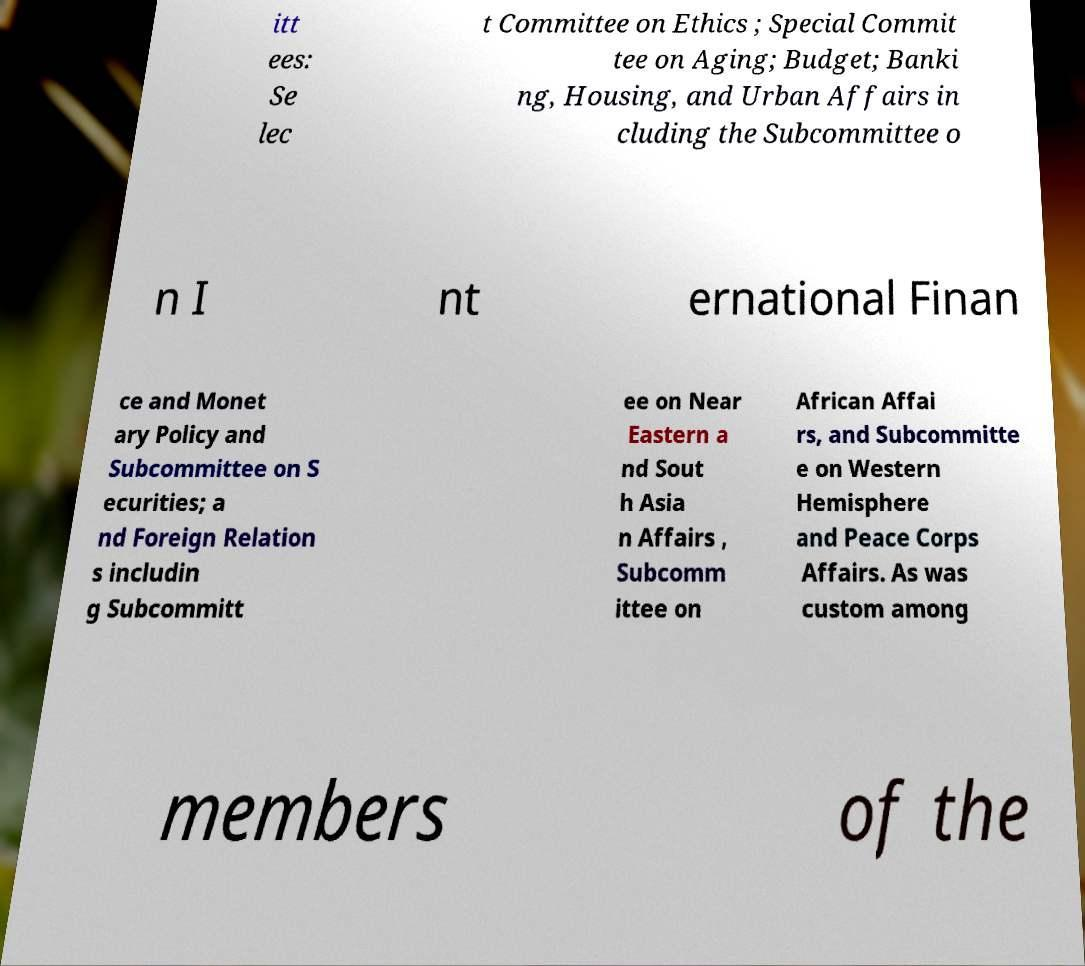Please identify and transcribe the text found in this image. itt ees: Se lec t Committee on Ethics ; Special Commit tee on Aging; Budget; Banki ng, Housing, and Urban Affairs in cluding the Subcommittee o n I nt ernational Finan ce and Monet ary Policy and Subcommittee on S ecurities; a nd Foreign Relation s includin g Subcommitt ee on Near Eastern a nd Sout h Asia n Affairs , Subcomm ittee on African Affai rs, and Subcommitte e on Western Hemisphere and Peace Corps Affairs. As was custom among members of the 